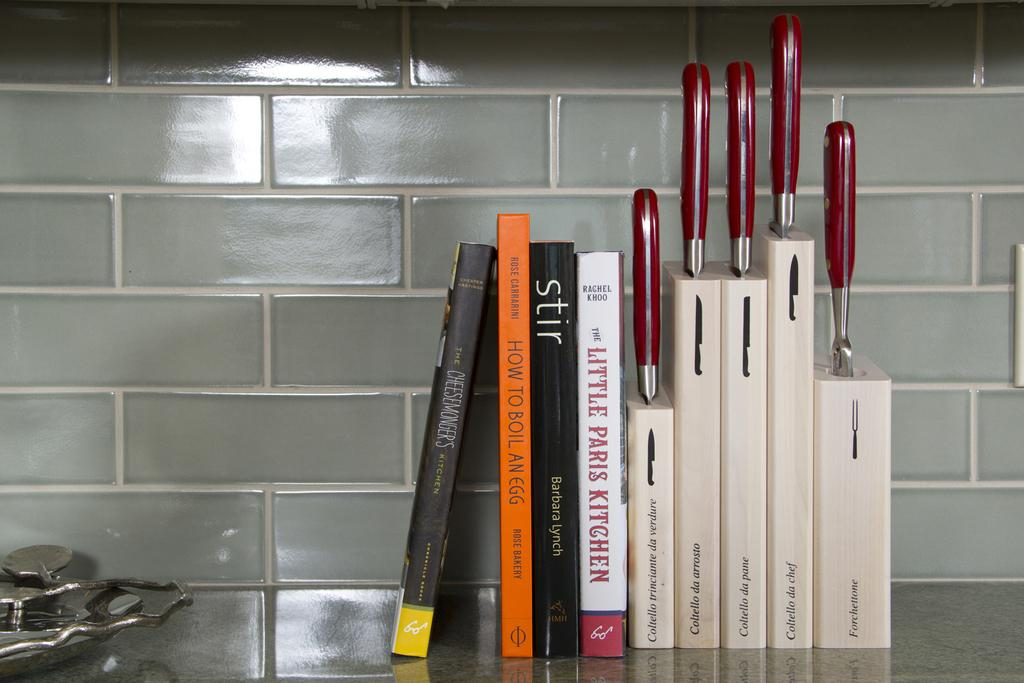<image>
Write a terse but informative summary of the picture. a few books with one saying The Little Paris Kitchen on it 